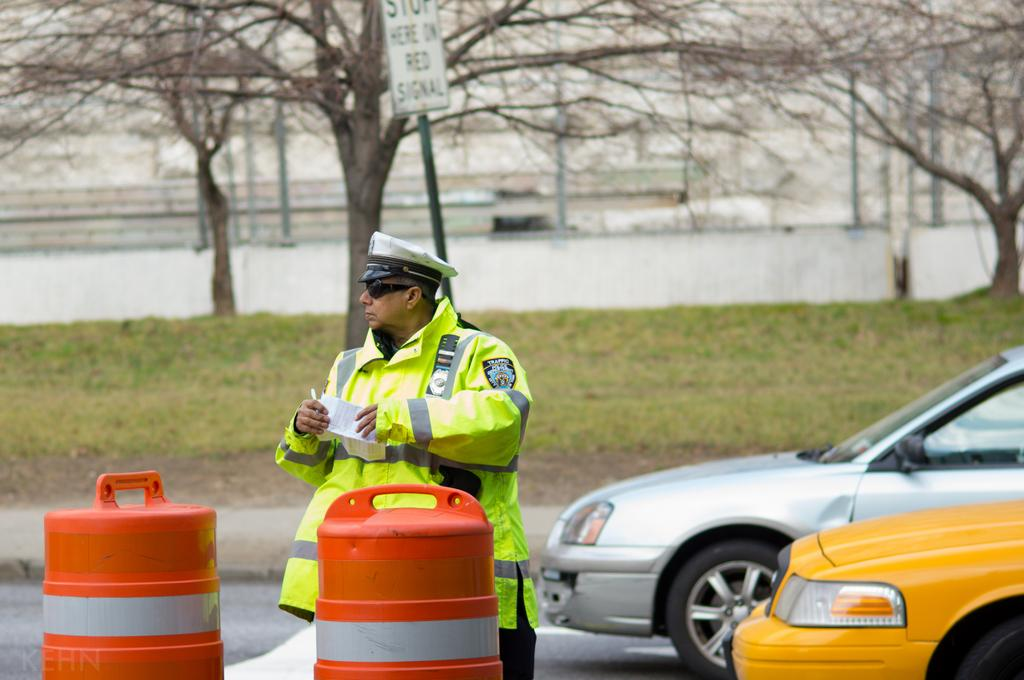<image>
Share a concise interpretation of the image provided. The traffic copy is making sure people stop in the proper spot during the red signal. 